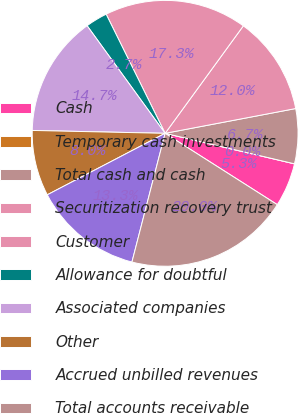Convert chart. <chart><loc_0><loc_0><loc_500><loc_500><pie_chart><fcel>Cash<fcel>Temporary cash investments<fcel>Total cash and cash<fcel>Securitization recovery trust<fcel>Customer<fcel>Allowance for doubtful<fcel>Associated companies<fcel>Other<fcel>Accrued unbilled revenues<fcel>Total accounts receivable<nl><fcel>5.33%<fcel>0.0%<fcel>6.67%<fcel>12.0%<fcel>17.33%<fcel>2.67%<fcel>14.67%<fcel>8.0%<fcel>13.33%<fcel>20.0%<nl></chart> 